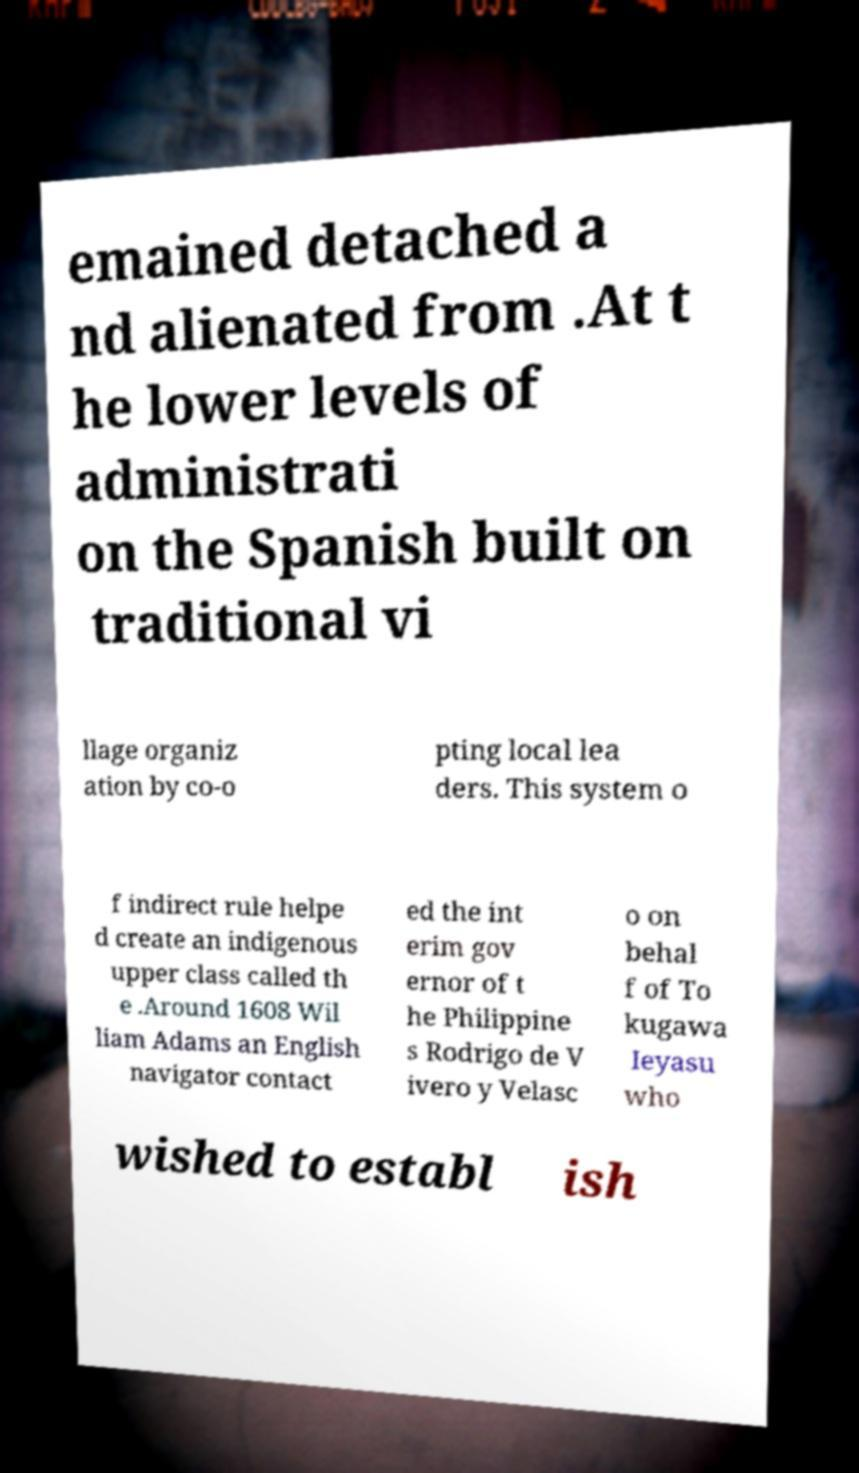For documentation purposes, I need the text within this image transcribed. Could you provide that? emained detached a nd alienated from .At t he lower levels of administrati on the Spanish built on traditional vi llage organiz ation by co-o pting local lea ders. This system o f indirect rule helpe d create an indigenous upper class called th e .Around 1608 Wil liam Adams an English navigator contact ed the int erim gov ernor of t he Philippine s Rodrigo de V ivero y Velasc o on behal f of To kugawa Ieyasu who wished to establ ish 